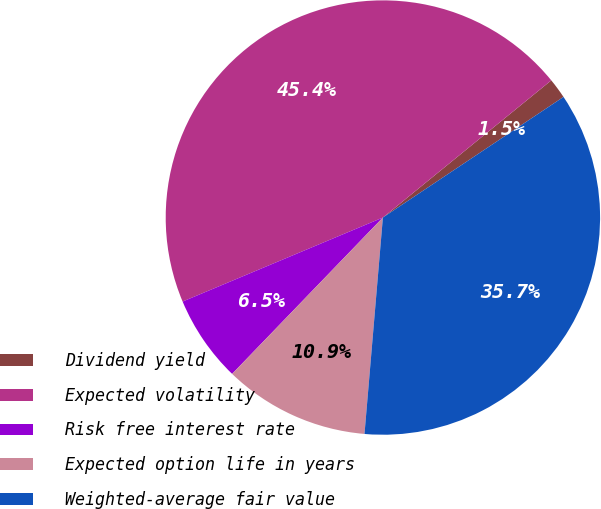<chart> <loc_0><loc_0><loc_500><loc_500><pie_chart><fcel>Dividend yield<fcel>Expected volatility<fcel>Risk free interest rate<fcel>Expected option life in years<fcel>Weighted-average fair value<nl><fcel>1.51%<fcel>45.44%<fcel>6.47%<fcel>10.86%<fcel>35.72%<nl></chart> 